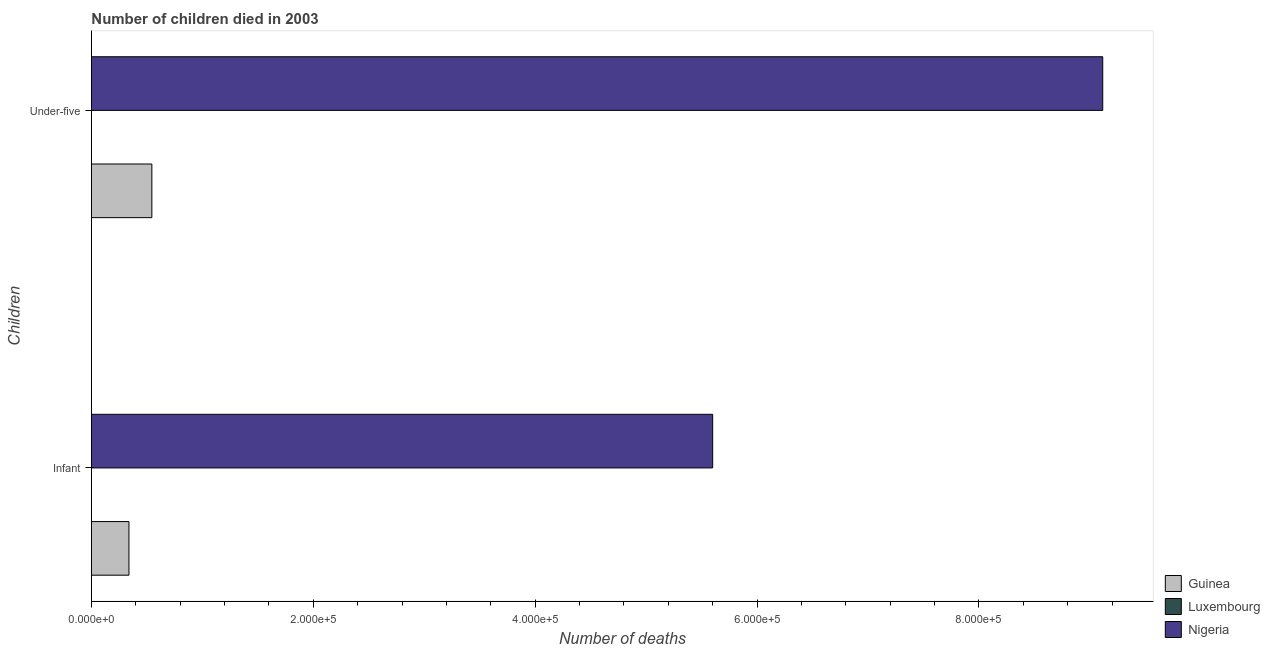How many different coloured bars are there?
Your response must be concise. 3. Are the number of bars per tick equal to the number of legend labels?
Your response must be concise. Yes. Are the number of bars on each tick of the Y-axis equal?
Offer a very short reply. Yes. How many bars are there on the 1st tick from the top?
Offer a very short reply. 3. How many bars are there on the 1st tick from the bottom?
Give a very brief answer. 3. What is the label of the 1st group of bars from the top?
Keep it short and to the point. Under-five. What is the number of under-five deaths in Nigeria?
Your response must be concise. 9.12e+05. Across all countries, what is the maximum number of infant deaths?
Offer a terse response. 5.60e+05. Across all countries, what is the minimum number of under-five deaths?
Offer a very short reply. 22. In which country was the number of infant deaths maximum?
Your answer should be compact. Nigeria. In which country was the number of infant deaths minimum?
Your answer should be very brief. Luxembourg. What is the total number of infant deaths in the graph?
Your answer should be compact. 5.94e+05. What is the difference between the number of under-five deaths in Nigeria and that in Luxembourg?
Your answer should be very brief. 9.12e+05. What is the difference between the number of infant deaths in Luxembourg and the number of under-five deaths in Guinea?
Your answer should be compact. -5.45e+04. What is the average number of infant deaths per country?
Ensure brevity in your answer.  1.98e+05. What is the difference between the number of under-five deaths and number of infant deaths in Nigeria?
Provide a short and direct response. 3.52e+05. What is the ratio of the number of infant deaths in Guinea to that in Nigeria?
Provide a succinct answer. 0.06. In how many countries, is the number of infant deaths greater than the average number of infant deaths taken over all countries?
Provide a short and direct response. 1. What does the 1st bar from the top in Under-five represents?
Your answer should be very brief. Nigeria. What does the 1st bar from the bottom in Under-five represents?
Ensure brevity in your answer.  Guinea. How many countries are there in the graph?
Keep it short and to the point. 3. Are the values on the major ticks of X-axis written in scientific E-notation?
Make the answer very short. Yes. How many legend labels are there?
Your response must be concise. 3. How are the legend labels stacked?
Your response must be concise. Vertical. What is the title of the graph?
Give a very brief answer. Number of children died in 2003. What is the label or title of the X-axis?
Your answer should be very brief. Number of deaths. What is the label or title of the Y-axis?
Keep it short and to the point. Children. What is the Number of deaths of Guinea in Infant?
Keep it short and to the point. 3.38e+04. What is the Number of deaths in Nigeria in Infant?
Provide a succinct answer. 5.60e+05. What is the Number of deaths of Guinea in Under-five?
Your answer should be compact. 5.45e+04. What is the Number of deaths in Nigeria in Under-five?
Your response must be concise. 9.12e+05. Across all Children, what is the maximum Number of deaths in Guinea?
Your answer should be very brief. 5.45e+04. Across all Children, what is the maximum Number of deaths of Luxembourg?
Offer a very short reply. 22. Across all Children, what is the maximum Number of deaths in Nigeria?
Your answer should be compact. 9.12e+05. Across all Children, what is the minimum Number of deaths in Guinea?
Ensure brevity in your answer.  3.38e+04. Across all Children, what is the minimum Number of deaths in Luxembourg?
Offer a very short reply. 17. Across all Children, what is the minimum Number of deaths in Nigeria?
Offer a terse response. 5.60e+05. What is the total Number of deaths of Guinea in the graph?
Offer a terse response. 8.83e+04. What is the total Number of deaths in Nigeria in the graph?
Make the answer very short. 1.47e+06. What is the difference between the Number of deaths in Guinea in Infant and that in Under-five?
Your response must be concise. -2.07e+04. What is the difference between the Number of deaths in Luxembourg in Infant and that in Under-five?
Your answer should be very brief. -5. What is the difference between the Number of deaths in Nigeria in Infant and that in Under-five?
Give a very brief answer. -3.52e+05. What is the difference between the Number of deaths of Guinea in Infant and the Number of deaths of Luxembourg in Under-five?
Your answer should be compact. 3.38e+04. What is the difference between the Number of deaths in Guinea in Infant and the Number of deaths in Nigeria in Under-five?
Keep it short and to the point. -8.78e+05. What is the difference between the Number of deaths of Luxembourg in Infant and the Number of deaths of Nigeria in Under-five?
Provide a succinct answer. -9.12e+05. What is the average Number of deaths of Guinea per Children?
Offer a terse response. 4.42e+04. What is the average Number of deaths of Nigeria per Children?
Offer a terse response. 7.36e+05. What is the difference between the Number of deaths in Guinea and Number of deaths in Luxembourg in Infant?
Offer a terse response. 3.38e+04. What is the difference between the Number of deaths of Guinea and Number of deaths of Nigeria in Infant?
Offer a terse response. -5.26e+05. What is the difference between the Number of deaths in Luxembourg and Number of deaths in Nigeria in Infant?
Keep it short and to the point. -5.60e+05. What is the difference between the Number of deaths of Guinea and Number of deaths of Luxembourg in Under-five?
Offer a very short reply. 5.45e+04. What is the difference between the Number of deaths in Guinea and Number of deaths in Nigeria in Under-five?
Keep it short and to the point. -8.57e+05. What is the difference between the Number of deaths of Luxembourg and Number of deaths of Nigeria in Under-five?
Provide a short and direct response. -9.12e+05. What is the ratio of the Number of deaths in Guinea in Infant to that in Under-five?
Offer a very short reply. 0.62. What is the ratio of the Number of deaths of Luxembourg in Infant to that in Under-five?
Make the answer very short. 0.77. What is the ratio of the Number of deaths in Nigeria in Infant to that in Under-five?
Offer a very short reply. 0.61. What is the difference between the highest and the second highest Number of deaths in Guinea?
Your answer should be compact. 2.07e+04. What is the difference between the highest and the second highest Number of deaths of Luxembourg?
Provide a short and direct response. 5. What is the difference between the highest and the second highest Number of deaths in Nigeria?
Your answer should be compact. 3.52e+05. What is the difference between the highest and the lowest Number of deaths of Guinea?
Offer a terse response. 2.07e+04. What is the difference between the highest and the lowest Number of deaths in Luxembourg?
Your response must be concise. 5. What is the difference between the highest and the lowest Number of deaths in Nigeria?
Keep it short and to the point. 3.52e+05. 